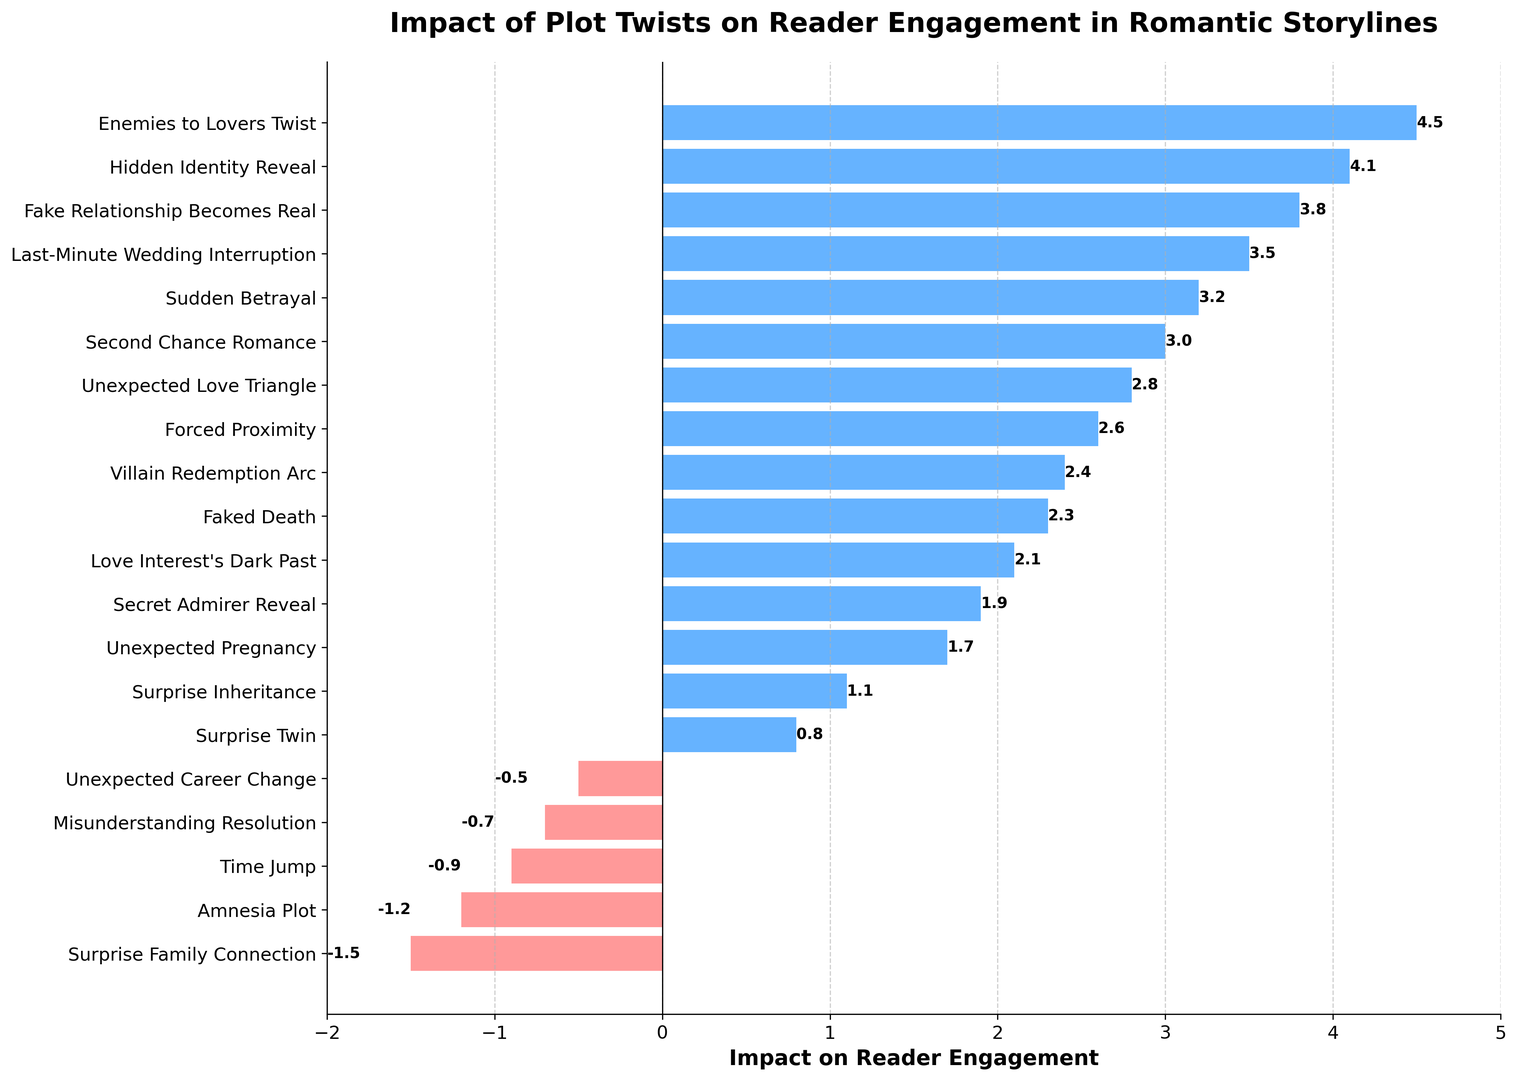Which plot twist has the highest positive impact on reader engagement? By observing the bar chart, the "Enemies to Lovers Twist" has the tallest bar extending the furthest to the right (positive direction), indicating the highest positive impact on reader engagement.
Answer: Enemies to Lovers Twist Which two plot twists have the largest negative impacts on reader engagement, and what are their values? The two plot twists with the largest negative impacts are "Surprise Family Connection" with -1.5 and "Amnesia Plot" with -1.2, as these have the longest bars extending to the left (negative direction).
Answer: Surprise Family Connection: -1.5, Amnesia Plot: -1.2 What is the combined impact of "Love Interest's Dark Past" and "Forced Proximity" on reader engagement? The impact of "Love Interest's Dark Past" is 2.1, and "Forced Proximity" is 2.6. Adding them together, 2.1 + 2.6 = 4.7.
Answer: 4.7 How does the impact of "Fake Relationship Becomes Real" compare to "Last-Minute Wedding Interruption"? The impact of "Fake Relationship Becomes Real" is 3.8, while "Last-Minute Wedding Interruption" is 3.5. Therefore, "Fake Relationship Becomes Real" has a slightly higher positive impact.
Answer: Fake Relationship Becomes Real > Last-Minute Wedding Interruption Which plot twist has an impact of exactly 3.0 on reader engagement, and where is it in the sorted list? By looking at the bars aligned horizontally, the plot twist with 3.0 impact is "Second Chance Romance". It is positioned among the positively impacting twists but not at the top.
Answer: Second Chance Romance How many plot twists have a negative impact on reader engagement? Count the number of bars extending to the left (negative values). There are five bars: "Surprise Family Connection," "Time Jump," "Amnesia Plot," "Misunderstanding Resolution," and "Unexpected Career Change".
Answer: Five Calculate the average impact of positive plot twists on reader engagement. First, list all the positive impacts and sum them: 2.8 + 3.2 + 4.1 + 1.7 + 2.3 + 3.5 + 1.9 + 4.5 + 2.6 + 1.1 + 3.8 + 2.1 + 0.8 + 3.0 + 2.4 = 39.7. There are 15 positive twists, so divide by 15: 39.7 / 15 = 2.65 approximately.
Answer: 2.65 Which plot twist has the closest impact to zero? By examining the horizontal bars, "Unexpected Career Change" has an impact of -0.5, which is the closest to zero.
Answer: Unexpected Career Change How much higher is the impact of "Enemies to Lovers Twist" compared to "Hidden Identity Reveal"? The impact of "Enemies to Lovers Twist" is 4.5, and "Hidden Identity Reveal" is 4.1. Subtracting these, 4.5 - 4.1 = 0.4.
Answer: 0.4 